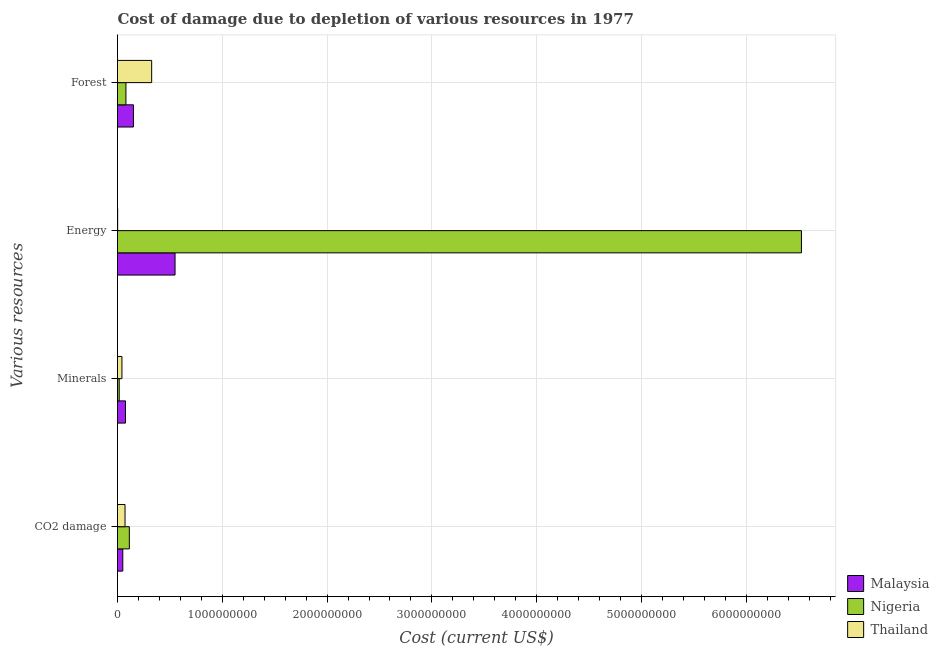How many different coloured bars are there?
Offer a very short reply. 3. Are the number of bars on each tick of the Y-axis equal?
Your answer should be very brief. Yes. How many bars are there on the 3rd tick from the top?
Keep it short and to the point. 3. How many bars are there on the 2nd tick from the bottom?
Give a very brief answer. 3. What is the label of the 2nd group of bars from the top?
Provide a succinct answer. Energy. What is the cost of damage due to depletion of coal in Nigeria?
Provide a short and direct response. 1.13e+08. Across all countries, what is the maximum cost of damage due to depletion of forests?
Your answer should be very brief. 3.26e+08. Across all countries, what is the minimum cost of damage due to depletion of coal?
Provide a short and direct response. 5.05e+07. In which country was the cost of damage due to depletion of forests maximum?
Provide a succinct answer. Thailand. In which country was the cost of damage due to depletion of forests minimum?
Ensure brevity in your answer.  Nigeria. What is the total cost of damage due to depletion of coal in the graph?
Offer a terse response. 2.35e+08. What is the difference between the cost of damage due to depletion of coal in Nigeria and that in Malaysia?
Your response must be concise. 6.24e+07. What is the difference between the cost of damage due to depletion of forests in Nigeria and the cost of damage due to depletion of minerals in Malaysia?
Offer a terse response. 4.33e+06. What is the average cost of damage due to depletion of minerals per country?
Your answer should be very brief. 4.49e+07. What is the difference between the cost of damage due to depletion of coal and cost of damage due to depletion of energy in Malaysia?
Make the answer very short. -4.99e+08. In how many countries, is the cost of damage due to depletion of minerals greater than 4200000000 US$?
Ensure brevity in your answer.  0. What is the ratio of the cost of damage due to depletion of energy in Nigeria to that in Malaysia?
Give a very brief answer. 11.89. Is the difference between the cost of damage due to depletion of coal in Thailand and Malaysia greater than the difference between the cost of damage due to depletion of energy in Thailand and Malaysia?
Provide a succinct answer. Yes. What is the difference between the highest and the second highest cost of damage due to depletion of coal?
Your response must be concise. 4.11e+07. What is the difference between the highest and the lowest cost of damage due to depletion of coal?
Give a very brief answer. 6.24e+07. In how many countries, is the cost of damage due to depletion of forests greater than the average cost of damage due to depletion of forests taken over all countries?
Make the answer very short. 1. Is the sum of the cost of damage due to depletion of minerals in Thailand and Malaysia greater than the maximum cost of damage due to depletion of energy across all countries?
Offer a very short reply. No. What does the 1st bar from the top in Minerals represents?
Ensure brevity in your answer.  Thailand. What does the 3rd bar from the bottom in Energy represents?
Keep it short and to the point. Thailand. Is it the case that in every country, the sum of the cost of damage due to depletion of coal and cost of damage due to depletion of minerals is greater than the cost of damage due to depletion of energy?
Provide a short and direct response. No. How many bars are there?
Provide a short and direct response. 12. Are all the bars in the graph horizontal?
Ensure brevity in your answer.  Yes. Does the graph contain any zero values?
Keep it short and to the point. No. Where does the legend appear in the graph?
Your answer should be compact. Bottom right. How are the legend labels stacked?
Your answer should be compact. Vertical. What is the title of the graph?
Offer a very short reply. Cost of damage due to depletion of various resources in 1977 . Does "Israel" appear as one of the legend labels in the graph?
Your response must be concise. No. What is the label or title of the X-axis?
Make the answer very short. Cost (current US$). What is the label or title of the Y-axis?
Make the answer very short. Various resources. What is the Cost (current US$) of Malaysia in CO2 damage?
Your response must be concise. 5.05e+07. What is the Cost (current US$) in Nigeria in CO2 damage?
Keep it short and to the point. 1.13e+08. What is the Cost (current US$) in Thailand in CO2 damage?
Provide a succinct answer. 7.18e+07. What is the Cost (current US$) of Malaysia in Minerals?
Provide a succinct answer. 7.62e+07. What is the Cost (current US$) of Nigeria in Minerals?
Offer a terse response. 1.63e+07. What is the Cost (current US$) in Thailand in Minerals?
Offer a terse response. 4.22e+07. What is the Cost (current US$) of Malaysia in Energy?
Your answer should be very brief. 5.49e+08. What is the Cost (current US$) in Nigeria in Energy?
Give a very brief answer. 6.53e+09. What is the Cost (current US$) in Thailand in Energy?
Keep it short and to the point. 1.53e+06. What is the Cost (current US$) in Malaysia in Forest?
Your response must be concise. 1.52e+08. What is the Cost (current US$) of Nigeria in Forest?
Provide a succinct answer. 8.05e+07. What is the Cost (current US$) in Thailand in Forest?
Ensure brevity in your answer.  3.26e+08. Across all Various resources, what is the maximum Cost (current US$) of Malaysia?
Ensure brevity in your answer.  5.49e+08. Across all Various resources, what is the maximum Cost (current US$) of Nigeria?
Give a very brief answer. 6.53e+09. Across all Various resources, what is the maximum Cost (current US$) in Thailand?
Offer a terse response. 3.26e+08. Across all Various resources, what is the minimum Cost (current US$) of Malaysia?
Make the answer very short. 5.05e+07. Across all Various resources, what is the minimum Cost (current US$) in Nigeria?
Give a very brief answer. 1.63e+07. Across all Various resources, what is the minimum Cost (current US$) of Thailand?
Make the answer very short. 1.53e+06. What is the total Cost (current US$) of Malaysia in the graph?
Ensure brevity in your answer.  8.28e+08. What is the total Cost (current US$) in Nigeria in the graph?
Your response must be concise. 6.74e+09. What is the total Cost (current US$) of Thailand in the graph?
Provide a succinct answer. 4.42e+08. What is the difference between the Cost (current US$) in Malaysia in CO2 damage and that in Minerals?
Keep it short and to the point. -2.57e+07. What is the difference between the Cost (current US$) of Nigeria in CO2 damage and that in Minerals?
Make the answer very short. 9.67e+07. What is the difference between the Cost (current US$) of Thailand in CO2 damage and that in Minerals?
Provide a short and direct response. 2.96e+07. What is the difference between the Cost (current US$) in Malaysia in CO2 damage and that in Energy?
Your response must be concise. -4.99e+08. What is the difference between the Cost (current US$) of Nigeria in CO2 damage and that in Energy?
Ensure brevity in your answer.  -6.41e+09. What is the difference between the Cost (current US$) in Thailand in CO2 damage and that in Energy?
Provide a succinct answer. 7.03e+07. What is the difference between the Cost (current US$) in Malaysia in CO2 damage and that in Forest?
Your answer should be compact. -1.02e+08. What is the difference between the Cost (current US$) in Nigeria in CO2 damage and that in Forest?
Keep it short and to the point. 3.24e+07. What is the difference between the Cost (current US$) of Thailand in CO2 damage and that in Forest?
Your response must be concise. -2.54e+08. What is the difference between the Cost (current US$) of Malaysia in Minerals and that in Energy?
Your answer should be compact. -4.73e+08. What is the difference between the Cost (current US$) in Nigeria in Minerals and that in Energy?
Keep it short and to the point. -6.51e+09. What is the difference between the Cost (current US$) in Thailand in Minerals and that in Energy?
Your answer should be very brief. 4.07e+07. What is the difference between the Cost (current US$) in Malaysia in Minerals and that in Forest?
Offer a very short reply. -7.58e+07. What is the difference between the Cost (current US$) of Nigeria in Minerals and that in Forest?
Your response must be concise. -6.43e+07. What is the difference between the Cost (current US$) in Thailand in Minerals and that in Forest?
Offer a terse response. -2.84e+08. What is the difference between the Cost (current US$) of Malaysia in Energy and that in Forest?
Your answer should be compact. 3.97e+08. What is the difference between the Cost (current US$) of Nigeria in Energy and that in Forest?
Your answer should be very brief. 6.45e+09. What is the difference between the Cost (current US$) of Thailand in Energy and that in Forest?
Give a very brief answer. -3.24e+08. What is the difference between the Cost (current US$) of Malaysia in CO2 damage and the Cost (current US$) of Nigeria in Minerals?
Offer a terse response. 3.42e+07. What is the difference between the Cost (current US$) of Malaysia in CO2 damage and the Cost (current US$) of Thailand in Minerals?
Your response must be concise. 8.26e+06. What is the difference between the Cost (current US$) of Nigeria in CO2 damage and the Cost (current US$) of Thailand in Minerals?
Keep it short and to the point. 7.07e+07. What is the difference between the Cost (current US$) of Malaysia in CO2 damage and the Cost (current US$) of Nigeria in Energy?
Your answer should be compact. -6.48e+09. What is the difference between the Cost (current US$) of Malaysia in CO2 damage and the Cost (current US$) of Thailand in Energy?
Offer a terse response. 4.90e+07. What is the difference between the Cost (current US$) in Nigeria in CO2 damage and the Cost (current US$) in Thailand in Energy?
Give a very brief answer. 1.11e+08. What is the difference between the Cost (current US$) in Malaysia in CO2 damage and the Cost (current US$) in Nigeria in Forest?
Offer a terse response. -3.00e+07. What is the difference between the Cost (current US$) in Malaysia in CO2 damage and the Cost (current US$) in Thailand in Forest?
Keep it short and to the point. -2.76e+08. What is the difference between the Cost (current US$) of Nigeria in CO2 damage and the Cost (current US$) of Thailand in Forest?
Offer a very short reply. -2.13e+08. What is the difference between the Cost (current US$) of Malaysia in Minerals and the Cost (current US$) of Nigeria in Energy?
Your response must be concise. -6.45e+09. What is the difference between the Cost (current US$) in Malaysia in Minerals and the Cost (current US$) in Thailand in Energy?
Give a very brief answer. 7.47e+07. What is the difference between the Cost (current US$) in Nigeria in Minerals and the Cost (current US$) in Thailand in Energy?
Give a very brief answer. 1.47e+07. What is the difference between the Cost (current US$) of Malaysia in Minerals and the Cost (current US$) of Nigeria in Forest?
Make the answer very short. -4.33e+06. What is the difference between the Cost (current US$) of Malaysia in Minerals and the Cost (current US$) of Thailand in Forest?
Keep it short and to the point. -2.50e+08. What is the difference between the Cost (current US$) of Nigeria in Minerals and the Cost (current US$) of Thailand in Forest?
Make the answer very short. -3.10e+08. What is the difference between the Cost (current US$) of Malaysia in Energy and the Cost (current US$) of Nigeria in Forest?
Offer a terse response. 4.68e+08. What is the difference between the Cost (current US$) of Malaysia in Energy and the Cost (current US$) of Thailand in Forest?
Provide a short and direct response. 2.23e+08. What is the difference between the Cost (current US$) in Nigeria in Energy and the Cost (current US$) in Thailand in Forest?
Keep it short and to the point. 6.20e+09. What is the average Cost (current US$) in Malaysia per Various resources?
Your response must be concise. 2.07e+08. What is the average Cost (current US$) in Nigeria per Various resources?
Your response must be concise. 1.68e+09. What is the average Cost (current US$) in Thailand per Various resources?
Ensure brevity in your answer.  1.10e+08. What is the difference between the Cost (current US$) of Malaysia and Cost (current US$) of Nigeria in CO2 damage?
Give a very brief answer. -6.24e+07. What is the difference between the Cost (current US$) of Malaysia and Cost (current US$) of Thailand in CO2 damage?
Your answer should be very brief. -2.13e+07. What is the difference between the Cost (current US$) in Nigeria and Cost (current US$) in Thailand in CO2 damage?
Offer a terse response. 4.11e+07. What is the difference between the Cost (current US$) of Malaysia and Cost (current US$) of Nigeria in Minerals?
Your response must be concise. 5.99e+07. What is the difference between the Cost (current US$) in Malaysia and Cost (current US$) in Thailand in Minerals?
Provide a short and direct response. 3.39e+07. What is the difference between the Cost (current US$) of Nigeria and Cost (current US$) of Thailand in Minerals?
Give a very brief answer. -2.60e+07. What is the difference between the Cost (current US$) in Malaysia and Cost (current US$) in Nigeria in Energy?
Your answer should be very brief. -5.98e+09. What is the difference between the Cost (current US$) in Malaysia and Cost (current US$) in Thailand in Energy?
Make the answer very short. 5.47e+08. What is the difference between the Cost (current US$) in Nigeria and Cost (current US$) in Thailand in Energy?
Give a very brief answer. 6.52e+09. What is the difference between the Cost (current US$) of Malaysia and Cost (current US$) of Nigeria in Forest?
Ensure brevity in your answer.  7.15e+07. What is the difference between the Cost (current US$) in Malaysia and Cost (current US$) in Thailand in Forest?
Give a very brief answer. -1.74e+08. What is the difference between the Cost (current US$) of Nigeria and Cost (current US$) of Thailand in Forest?
Make the answer very short. -2.46e+08. What is the ratio of the Cost (current US$) in Malaysia in CO2 damage to that in Minerals?
Provide a succinct answer. 0.66. What is the ratio of the Cost (current US$) of Nigeria in CO2 damage to that in Minerals?
Make the answer very short. 6.95. What is the ratio of the Cost (current US$) in Thailand in CO2 damage to that in Minerals?
Your answer should be compact. 1.7. What is the ratio of the Cost (current US$) in Malaysia in CO2 damage to that in Energy?
Offer a terse response. 0.09. What is the ratio of the Cost (current US$) of Nigeria in CO2 damage to that in Energy?
Ensure brevity in your answer.  0.02. What is the ratio of the Cost (current US$) in Thailand in CO2 damage to that in Energy?
Offer a very short reply. 46.97. What is the ratio of the Cost (current US$) of Malaysia in CO2 damage to that in Forest?
Offer a very short reply. 0.33. What is the ratio of the Cost (current US$) of Nigeria in CO2 damage to that in Forest?
Your response must be concise. 1.4. What is the ratio of the Cost (current US$) in Thailand in CO2 damage to that in Forest?
Make the answer very short. 0.22. What is the ratio of the Cost (current US$) of Malaysia in Minerals to that in Energy?
Provide a short and direct response. 0.14. What is the ratio of the Cost (current US$) in Nigeria in Minerals to that in Energy?
Provide a short and direct response. 0. What is the ratio of the Cost (current US$) in Thailand in Minerals to that in Energy?
Give a very brief answer. 27.62. What is the ratio of the Cost (current US$) of Malaysia in Minerals to that in Forest?
Give a very brief answer. 0.5. What is the ratio of the Cost (current US$) of Nigeria in Minerals to that in Forest?
Give a very brief answer. 0.2. What is the ratio of the Cost (current US$) in Thailand in Minerals to that in Forest?
Your response must be concise. 0.13. What is the ratio of the Cost (current US$) of Malaysia in Energy to that in Forest?
Make the answer very short. 3.61. What is the ratio of the Cost (current US$) of Nigeria in Energy to that in Forest?
Your response must be concise. 81.05. What is the ratio of the Cost (current US$) of Thailand in Energy to that in Forest?
Your response must be concise. 0. What is the difference between the highest and the second highest Cost (current US$) in Malaysia?
Offer a terse response. 3.97e+08. What is the difference between the highest and the second highest Cost (current US$) in Nigeria?
Provide a short and direct response. 6.41e+09. What is the difference between the highest and the second highest Cost (current US$) in Thailand?
Keep it short and to the point. 2.54e+08. What is the difference between the highest and the lowest Cost (current US$) of Malaysia?
Your response must be concise. 4.99e+08. What is the difference between the highest and the lowest Cost (current US$) of Nigeria?
Ensure brevity in your answer.  6.51e+09. What is the difference between the highest and the lowest Cost (current US$) of Thailand?
Provide a short and direct response. 3.24e+08. 